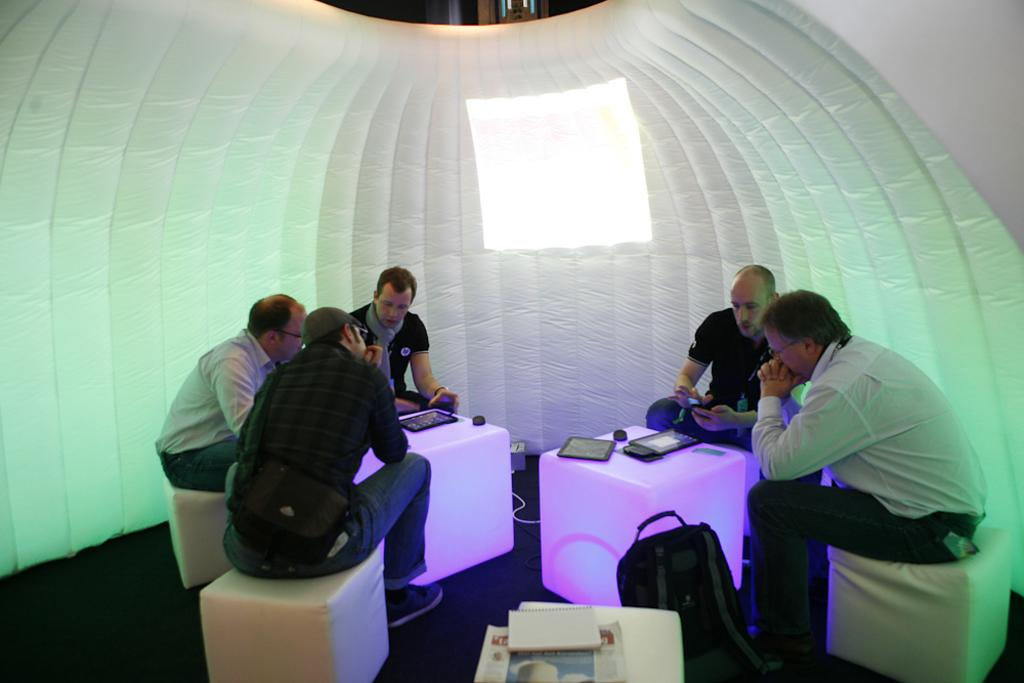What are the people in the image doing? The people in the image are sitting on chairs. What can be seen at the top of the image? There is a wall at the top of the image. What is providing illumination in the image? There is a light in the image. Where is the bag located in the image? The bag is in the bottom right side of the image. Can you see a gun in the image? No, there is no gun present in the image. 